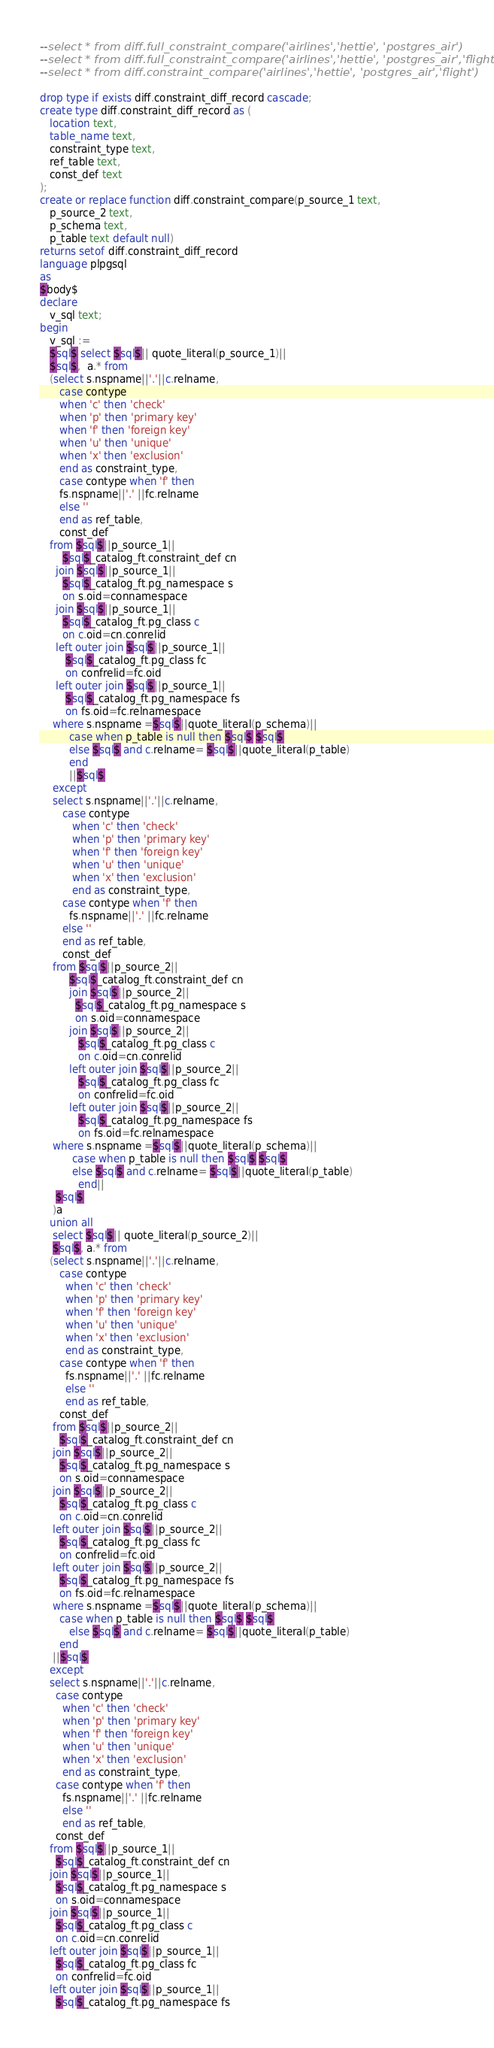<code> <loc_0><loc_0><loc_500><loc_500><_SQL_>--select * from diff.full_constraint_compare('airlines','hettie', 'postgres_air')
--select * from diff.full_constraint_compare('airlines','hettie', 'postgres_air','flight')
--select * from diff.constraint_compare('airlines','hettie', 'postgres_air','flight')

drop type if exists diff.constraint_diff_record cascade;
create type diff.constraint_diff_record as (
   location text,
   table_name text,
   constraint_type text,
   ref_table text,
   const_def text
);
create or replace function diff.constraint_compare(p_source_1 text,
   p_source_2 text,
   p_schema text, 
   p_table text default null)
returns setof diff.constraint_diff_record
language plpgsql
as
$body$
declare
   v_sql text;
begin
   v_sql := 
   $sql$ select $sql$|| quote_literal(p_source_1)||
   $sql$,  a.* from
   (select s.nspname||'.'||c.relname, 
      case contype
      when 'c' then 'check'
      when 'p' then 'primary key'
      when 'f' then 'foreign key'
      when 'u' then 'unique'
      when 'x' then 'exclusion'
      end as constraint_type, 
      case contype when 'f' then
      fs.nspname||'.' ||fc.relname
      else ''
      end as ref_table,
      const_def
   from $sql$||p_source_1||
       $sql$_catalog_ft.constraint_def cn
     join $sql$||p_source_1||
       $sql$_catalog_ft.pg_namespace s
       on s.oid=connamespace
     join $sql$||p_source_1||
       $sql$_catalog_ft.pg_class c 
       on c.oid=cn.conrelid
     left outer join $sql$||p_source_1||
        $sql$_catalog_ft.pg_class fc
        on confrelid=fc.oid
     left outer join $sql$||p_source_1||
        $sql$_catalog_ft.pg_namespace fs
        on fs.oid=fc.relnamespace
    where s.nspname =$sql$||quote_literal(p_schema)||
         case when p_table is null then $sql$ $sql$  
         else $sql$ and c.relname= $sql$||quote_literal(p_table)
   	     end
   	     ||$sql$ 
    except 
    select s.nspname||'.'||c.relname, 
       case contype
          when 'c' then 'check'
          when 'p' then 'primary key'
          when 'f' then 'foreign key'
          when 'u' then 'unique'
          when 'x' then 'exclusion'
          end as constraint_type, 
       case contype when 'f' then
         fs.nspname||'.' ||fc.relname
       else ''
       end as ref_table,
       const_def
    from $sql$||p_source_2||
         $sql$_catalog_ft.constraint_def cn
         join $sql$||p_source_2||
           $sql$_catalog_ft.pg_namespace s
           on s.oid=connamespace
         join $sql$||p_source_2||
            $sql$_catalog_ft.pg_class c 
            on c.oid=cn.conrelid
         left outer join $sql$||p_source_2||
            $sql$_catalog_ft.pg_class fc
            on confrelid=fc.oid
         left outer join $sql$||p_source_2||
            $sql$_catalog_ft.pg_namespace fs
            on fs.oid=fc.relnamespace
    where s.nspname =$sql$||quote_literal(p_schema)||
          case when p_table is null then $sql$ $sql$  
          else $sql$ and c.relname= $sql$||quote_literal(p_table)
    	    end||
     $sql$	
    )a
   union all 
    select $sql$|| quote_literal(p_source_2)||
    $sql$, a.* from
   (select s.nspname||'.'||c.relname, 
      case contype
        when 'c' then 'check'
        when 'p' then 'primary key'
        when 'f' then 'foreign key'
        when 'u' then 'unique'
        when 'x' then 'exclusion'
        end as constraint_type, 
      case contype when 'f' then
        fs.nspname||'.' ||fc.relname
        else ''
        end as ref_table,
      const_def
    from $sql$||p_source_2||
      $sql$_catalog_ft.constraint_def cn
    join $sql$||p_source_2||
      $sql$_catalog_ft.pg_namespace s
      on s.oid=connamespace
    join $sql$||p_source_2||
      $sql$_catalog_ft.pg_class c 
      on c.oid=cn.conrelid
    left outer join $sql$||p_source_2||
      $sql$_catalog_ft.pg_class fc
      on confrelid=fc.oid
    left outer join $sql$||p_source_2||
      $sql$_catalog_ft.pg_namespace fs
      on fs.oid=fc.relnamespace
    where s.nspname =$sql$||quote_literal(p_schema)||
      case when p_table is null then $sql$ $sql$  
         else $sql$ and c.relname= $sql$||quote_literal(p_table)
   	  end
   	||$sql$
   except 
   select s.nspname||'.'||c.relname, 
     case contype
       when 'c' then 'check'
       when 'p' then 'primary key'
       when 'f' then 'foreign key'
       when 'u' then 'unique'
       when 'x' then 'exclusion'
       end as constraint_type,
     case contype when 'f' then
       fs.nspname||'.' ||fc.relname
       else ''
       end as ref_table,
     const_def
   from $sql$||p_source_1||
     $sql$_catalog_ft.constraint_def cn
   join $sql$||p_source_1||
     $sql$_catalog_ft.pg_namespace s
     on s.oid=connamespace
   join $sql$||p_source_1||
     $sql$_catalog_ft.pg_class c 
     on c.oid=cn.conrelid
   left outer join $sql$||p_source_1||
     $sql$_catalog_ft.pg_class fc
     on confrelid=fc.oid
   left outer join $sql$||p_source_1||
     $sql$_catalog_ft.pg_namespace fs</code> 